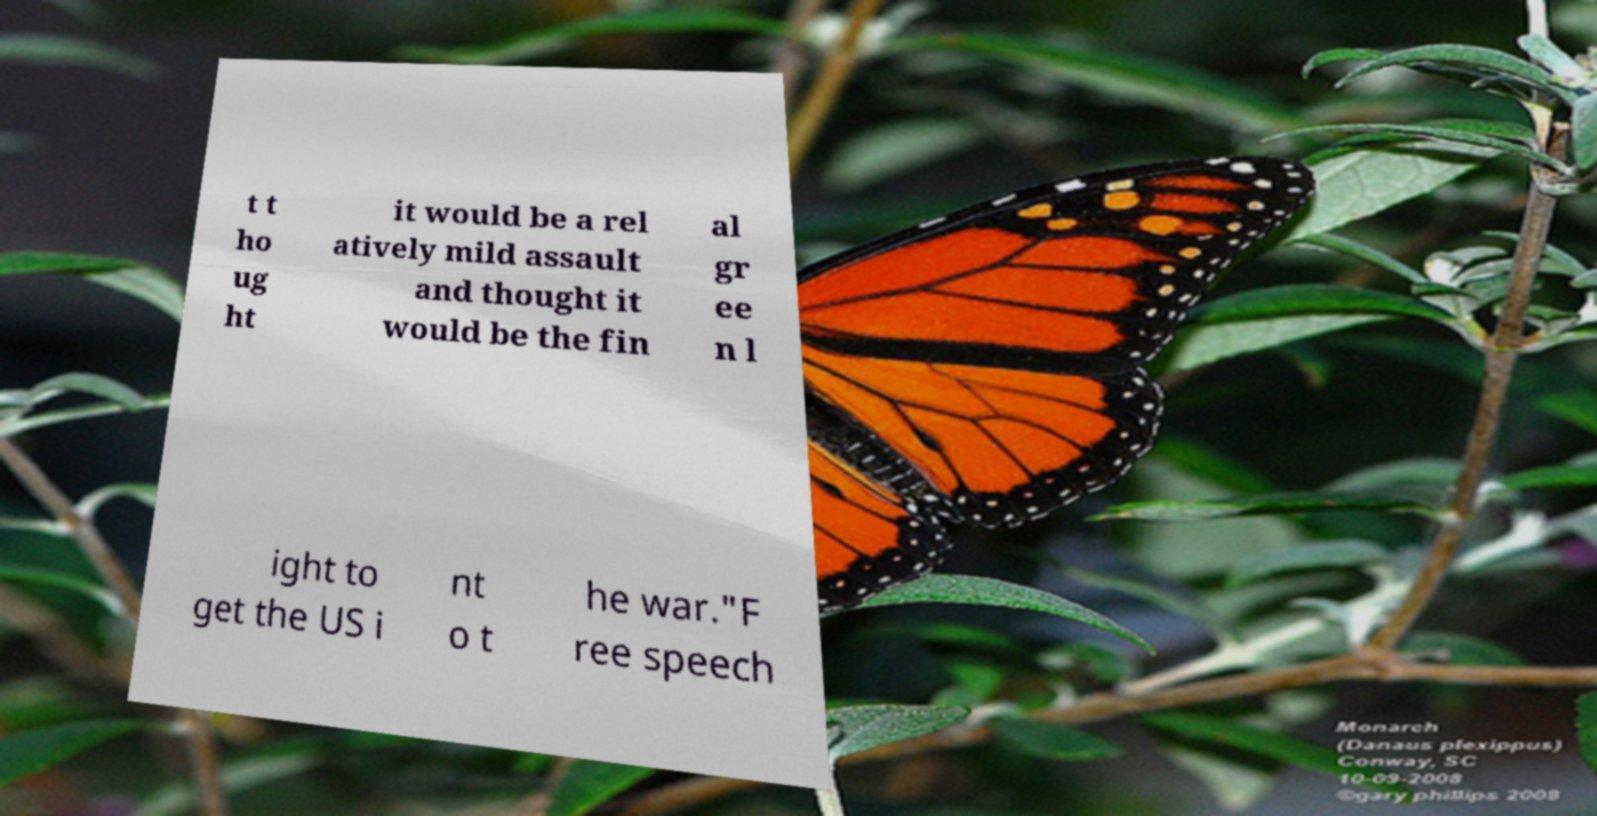For documentation purposes, I need the text within this image transcribed. Could you provide that? t t ho ug ht it would be a rel atively mild assault and thought it would be the fin al gr ee n l ight to get the US i nt o t he war."F ree speech 